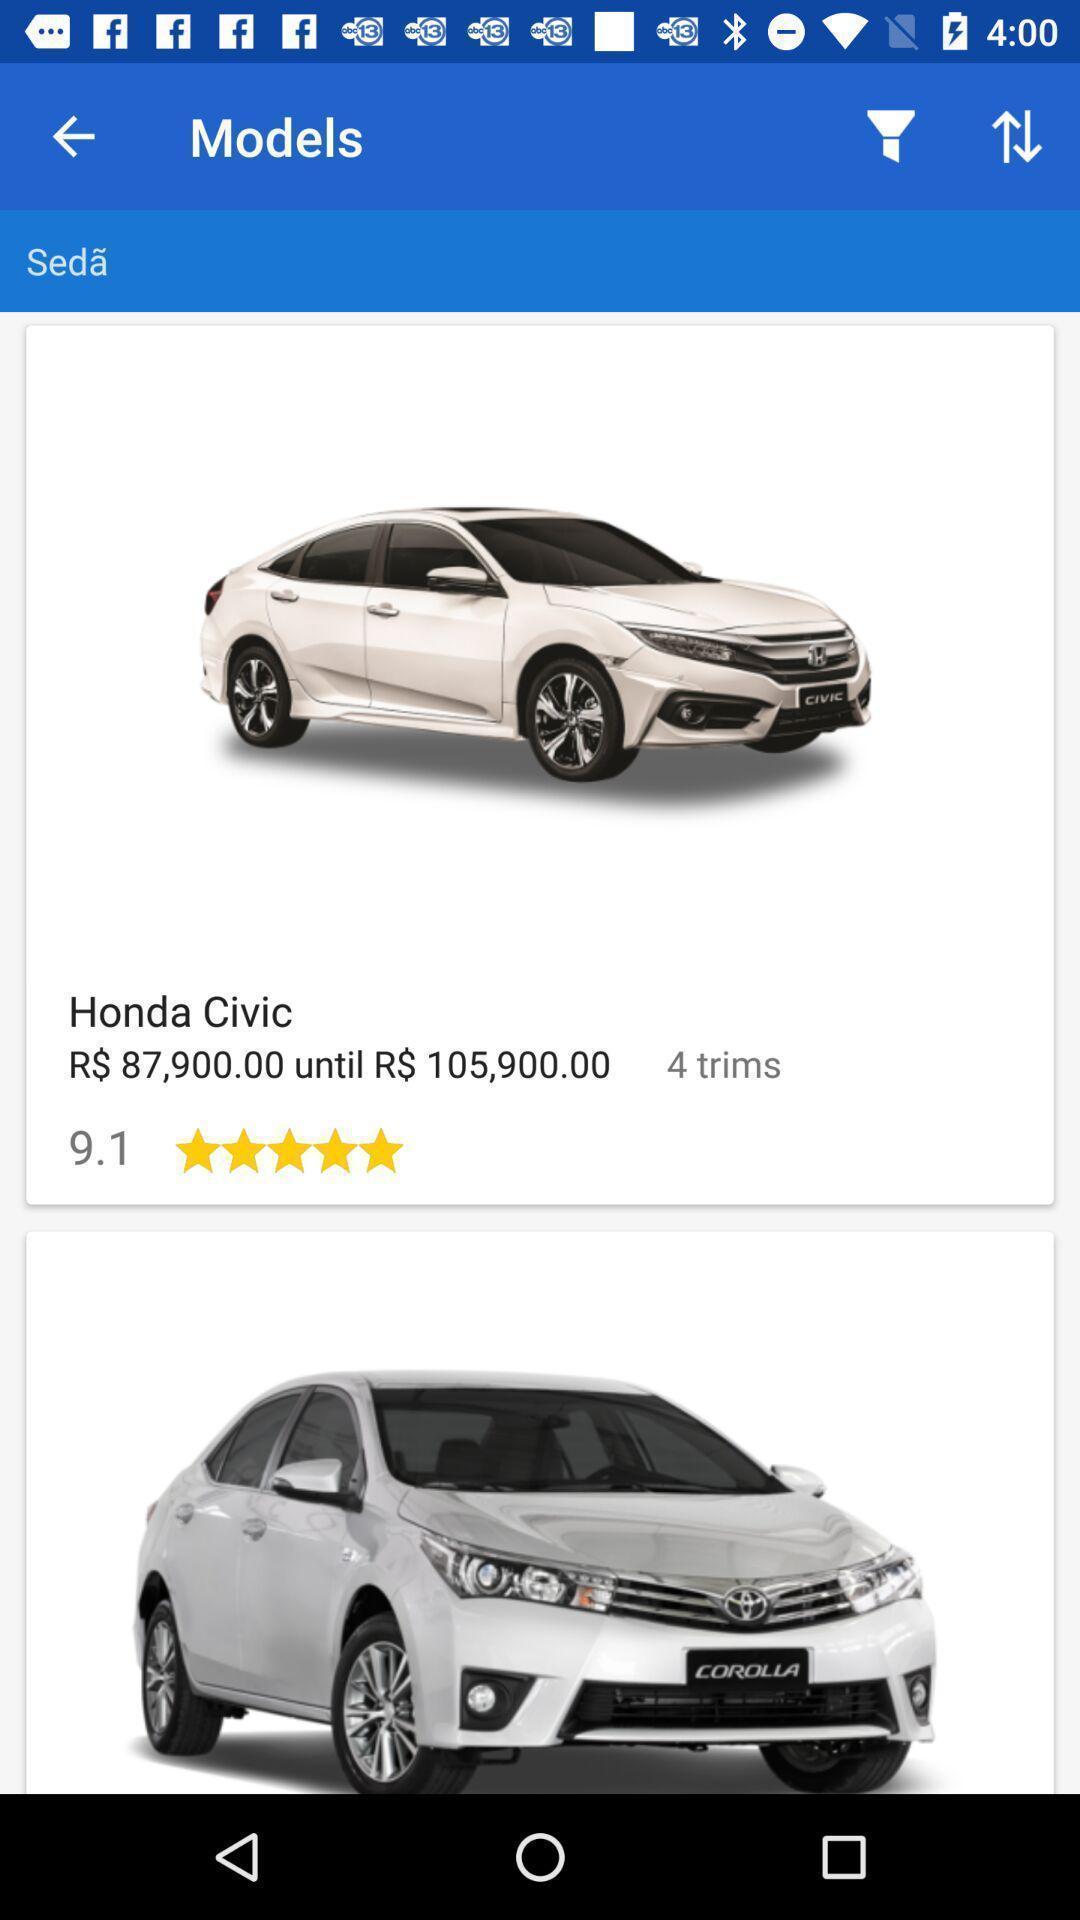Tell me about the visual elements in this screen capture. Screen displaying car model with price. 